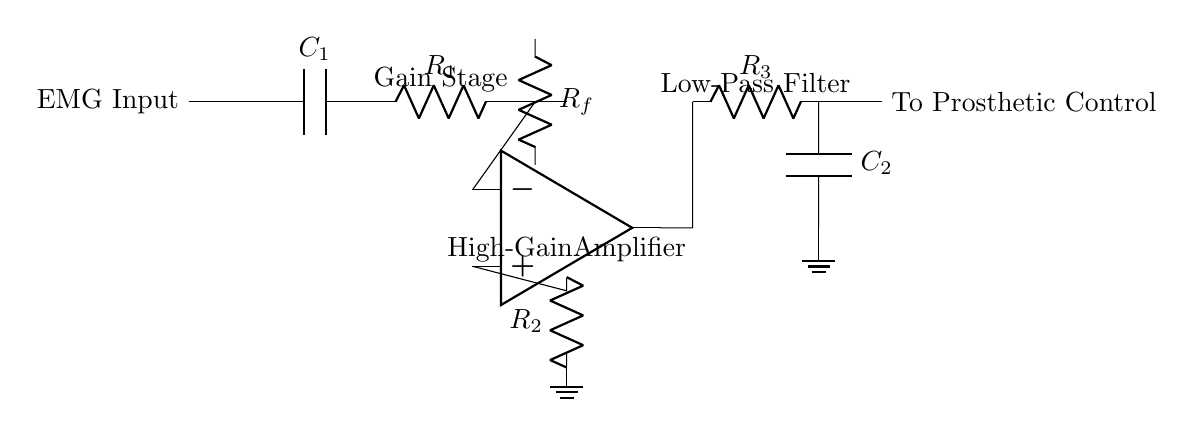What is the first component in the circuit? The first component is a capacitor labeled C1, which is connected to the EMG input. This is identified by its position on the left side of the diagram.
Answer: Capacitor C1 What is the function of the op-amp in this circuit? The op-amp functions as a high-gain amplifier. It is positioned in the middle section of the circuit, where it amplifies the muscle signals fed into the circuit for prosthetic control.
Answer: High-gain amplifier What value of resistance is used for Rf? The value of Rf is not explicitly mentioned in the circuit diagram. However, in a proportional circuit design, it would commonly be set based on the desired gain of the amplifier.
Answer: Not specified What connects the output of the op-amp to the next component? The output of the op-amp is connected to a resistor labeled R3, which is the first component in the low-pass filter section of the circuit. This connection can be seen moving to the right from the op-amp output.
Answer: Resistor R3 How many stages are there in this circuit? The circuit consists of three main stages: the gain stage, the high-gain amplifier, and the low-pass filter stage. Each stage serves a specific purpose in processing the EMG signals.
Answer: Three stages What is the input signal type for this circuit? The input signal type is an electromyography (EMG) signal, which is indicated at the beginning of the circuit before it connects to the capacitor C1.
Answer: EMG signal What is the purpose of the low-pass filter in the circuit? The low-pass filter, composed of resistor R3 and capacitor C2, removes high-frequency noise from the amplified signal, making the output signal cleaner and usable for prosthetic control.
Answer: Noise reduction 